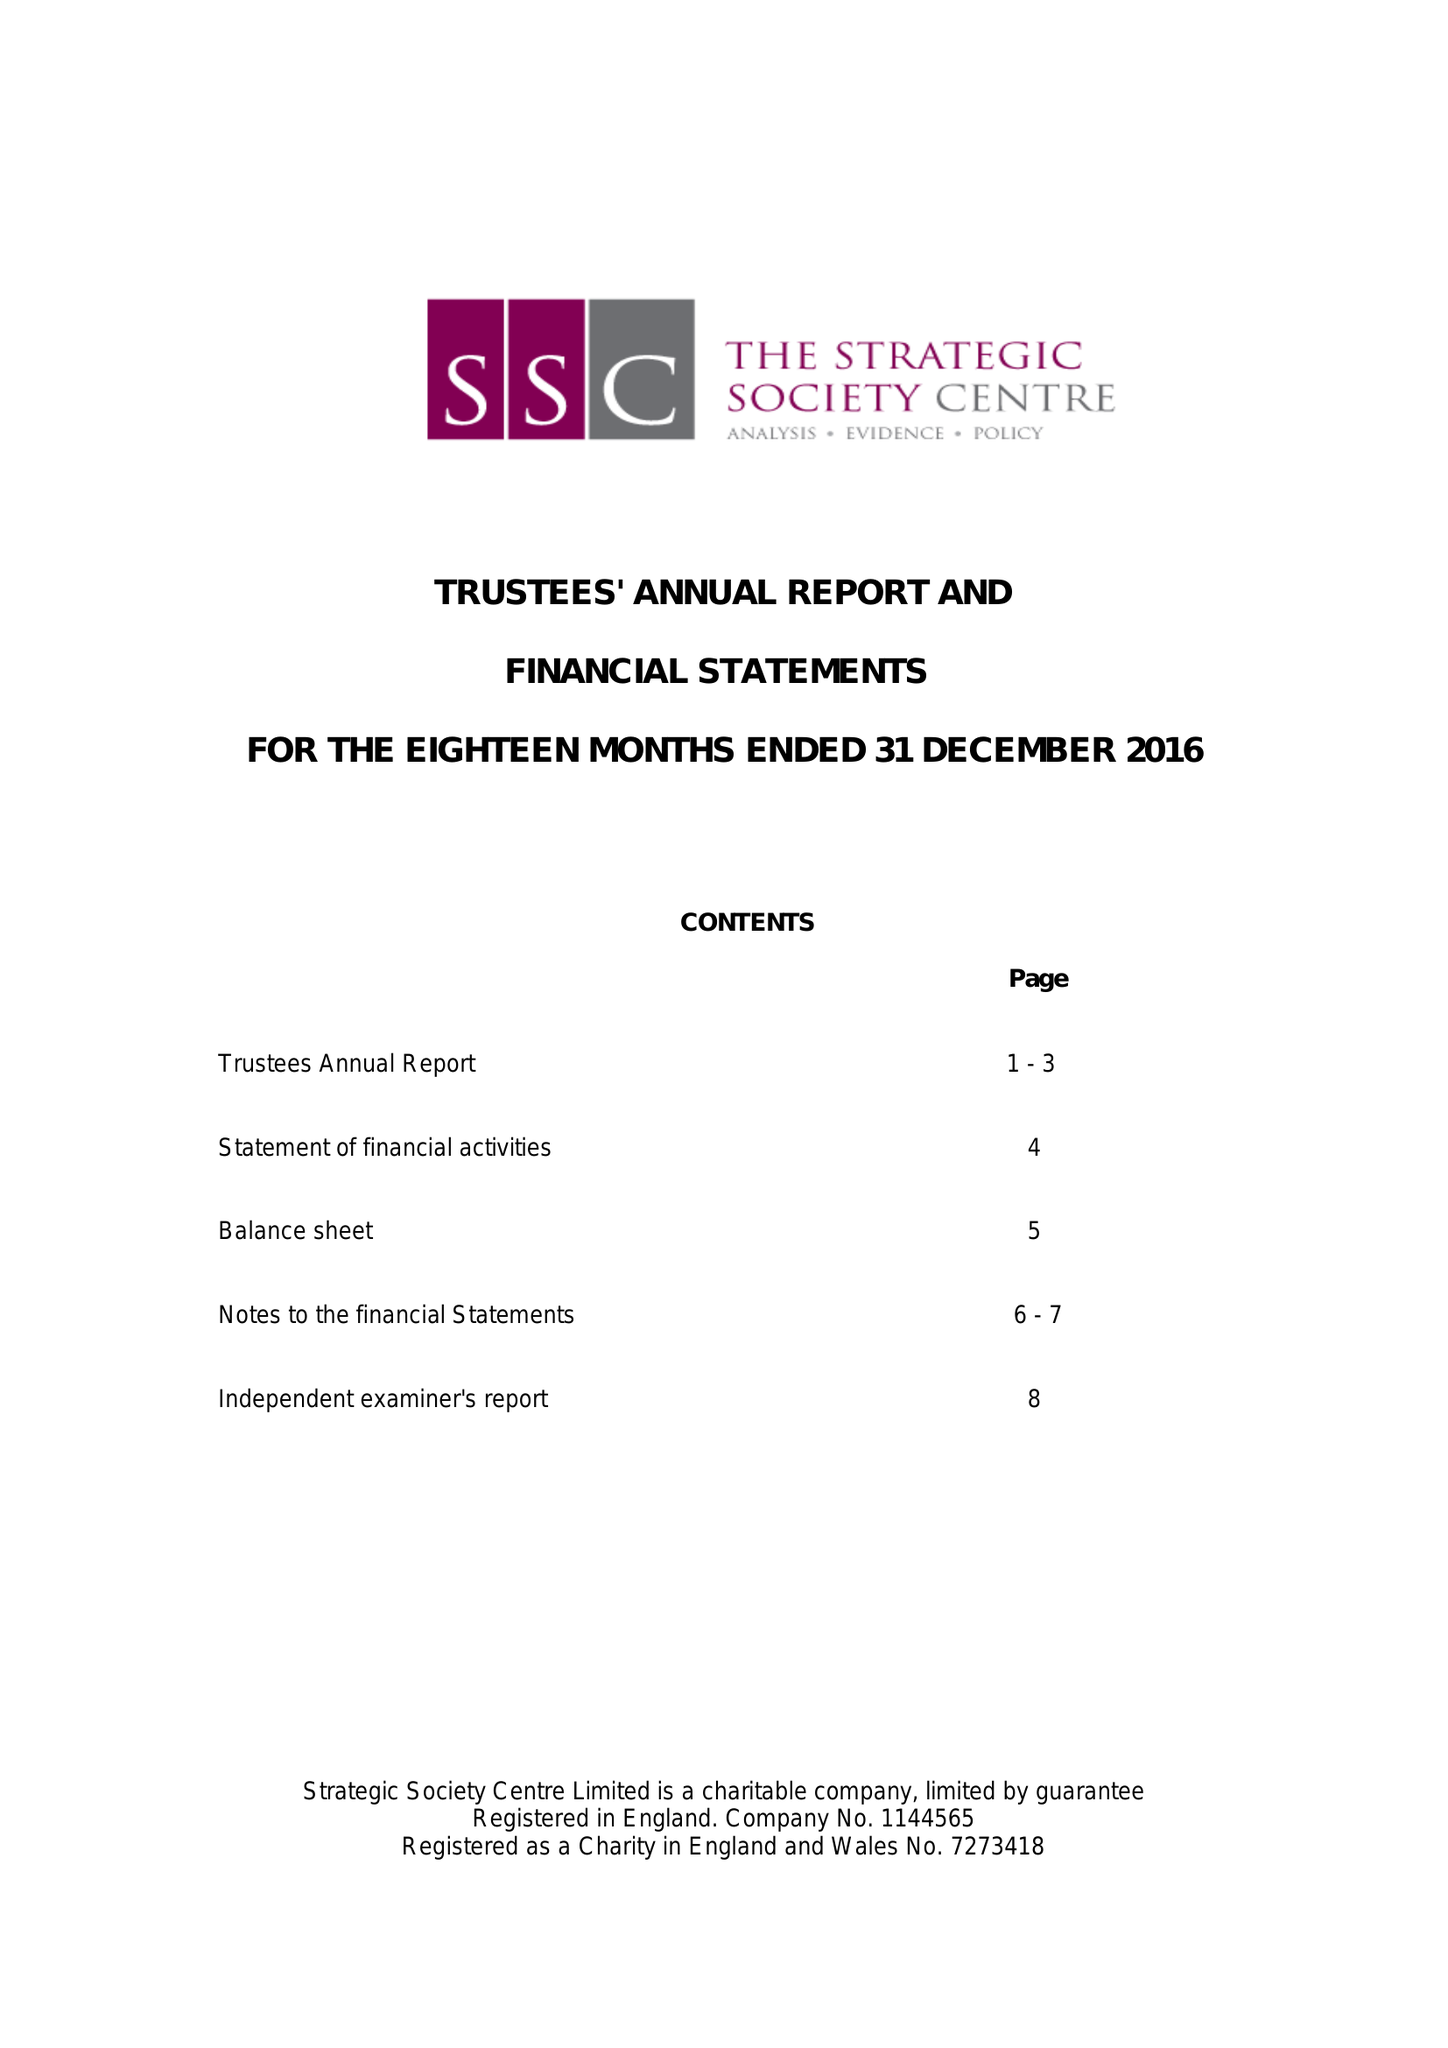What is the value for the address__post_town?
Answer the question using a single word or phrase. LONDON 